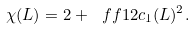<formula> <loc_0><loc_0><loc_500><loc_500>\chi ( L ) = 2 + \ f f { 1 } { 2 } c _ { 1 } ( L ) ^ { 2 } .</formula> 